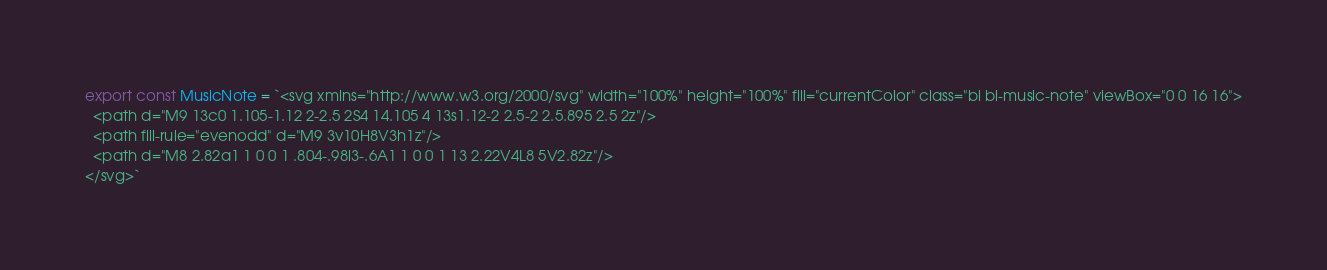<code> <loc_0><loc_0><loc_500><loc_500><_TypeScript_>export const MusicNote = `<svg xmlns="http://www.w3.org/2000/svg" width="100%" height="100%" fill="currentColor" class="bi bi-music-note" viewBox="0 0 16 16">
  <path d="M9 13c0 1.105-1.12 2-2.5 2S4 14.105 4 13s1.12-2 2.5-2 2.5.895 2.5 2z"/>
  <path fill-rule="evenodd" d="M9 3v10H8V3h1z"/>
  <path d="M8 2.82a1 1 0 0 1 .804-.98l3-.6A1 1 0 0 1 13 2.22V4L8 5V2.82z"/>
</svg>`
</code> 